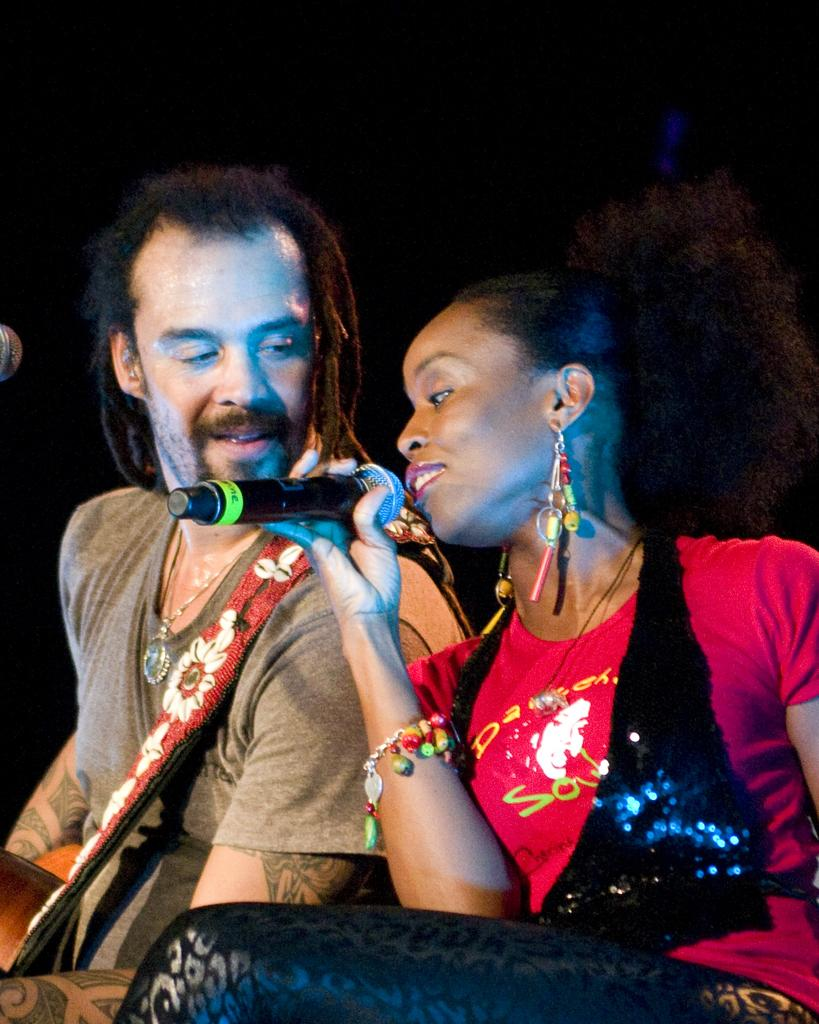What is the woman doing on the right side of the image? The woman is holding a microphone, and she may be singing. What is the man doing on the left side of the image? The man is holding a guitar. Can you describe the woman's position in the image? The woman is on the right side of the image. Can you describe the man's position in the image? The man is on the left side of the image. What type of cow can be seen in the library in the image? There is no cow or library present in the image; it features a woman holding a microphone and a man holding a guitar. 